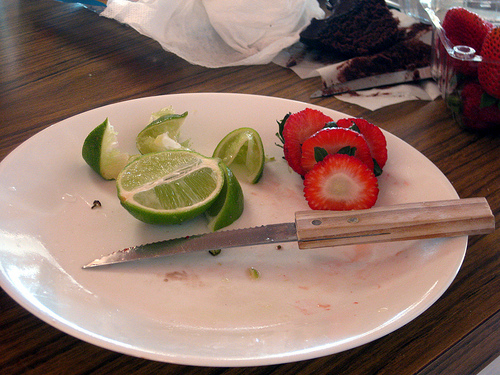<image>
Can you confirm if the plate is under the knife? Yes. The plate is positioned underneath the knife, with the knife above it in the vertical space. 